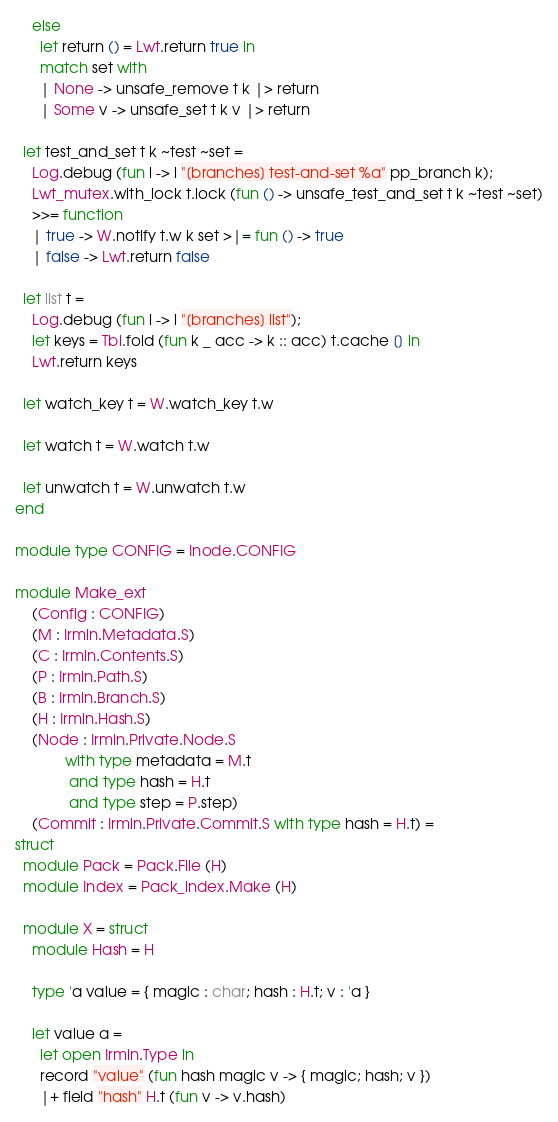Convert code to text. <code><loc_0><loc_0><loc_500><loc_500><_OCaml_>    else
      let return () = Lwt.return true in
      match set with
      | None -> unsafe_remove t k |> return
      | Some v -> unsafe_set t k v |> return

  let test_and_set t k ~test ~set =
    Log.debug (fun l -> l "[branches] test-and-set %a" pp_branch k);
    Lwt_mutex.with_lock t.lock (fun () -> unsafe_test_and_set t k ~test ~set)
    >>= function
    | true -> W.notify t.w k set >|= fun () -> true
    | false -> Lwt.return false

  let list t =
    Log.debug (fun l -> l "[branches] list");
    let keys = Tbl.fold (fun k _ acc -> k :: acc) t.cache [] in
    Lwt.return keys

  let watch_key t = W.watch_key t.w

  let watch t = W.watch t.w

  let unwatch t = W.unwatch t.w
end

module type CONFIG = Inode.CONFIG

module Make_ext
    (Config : CONFIG)
    (M : Irmin.Metadata.S)
    (C : Irmin.Contents.S)
    (P : Irmin.Path.S)
    (B : Irmin.Branch.S)
    (H : Irmin.Hash.S)
    (Node : Irmin.Private.Node.S
            with type metadata = M.t
             and type hash = H.t
             and type step = P.step)
    (Commit : Irmin.Private.Commit.S with type hash = H.t) =
struct
  module Pack = Pack.File (H)
  module Index = Pack_index.Make (H)

  module X = struct
    module Hash = H

    type 'a value = { magic : char; hash : H.t; v : 'a }

    let value a =
      let open Irmin.Type in
      record "value" (fun hash magic v -> { magic; hash; v })
      |+ field "hash" H.t (fun v -> v.hash)</code> 